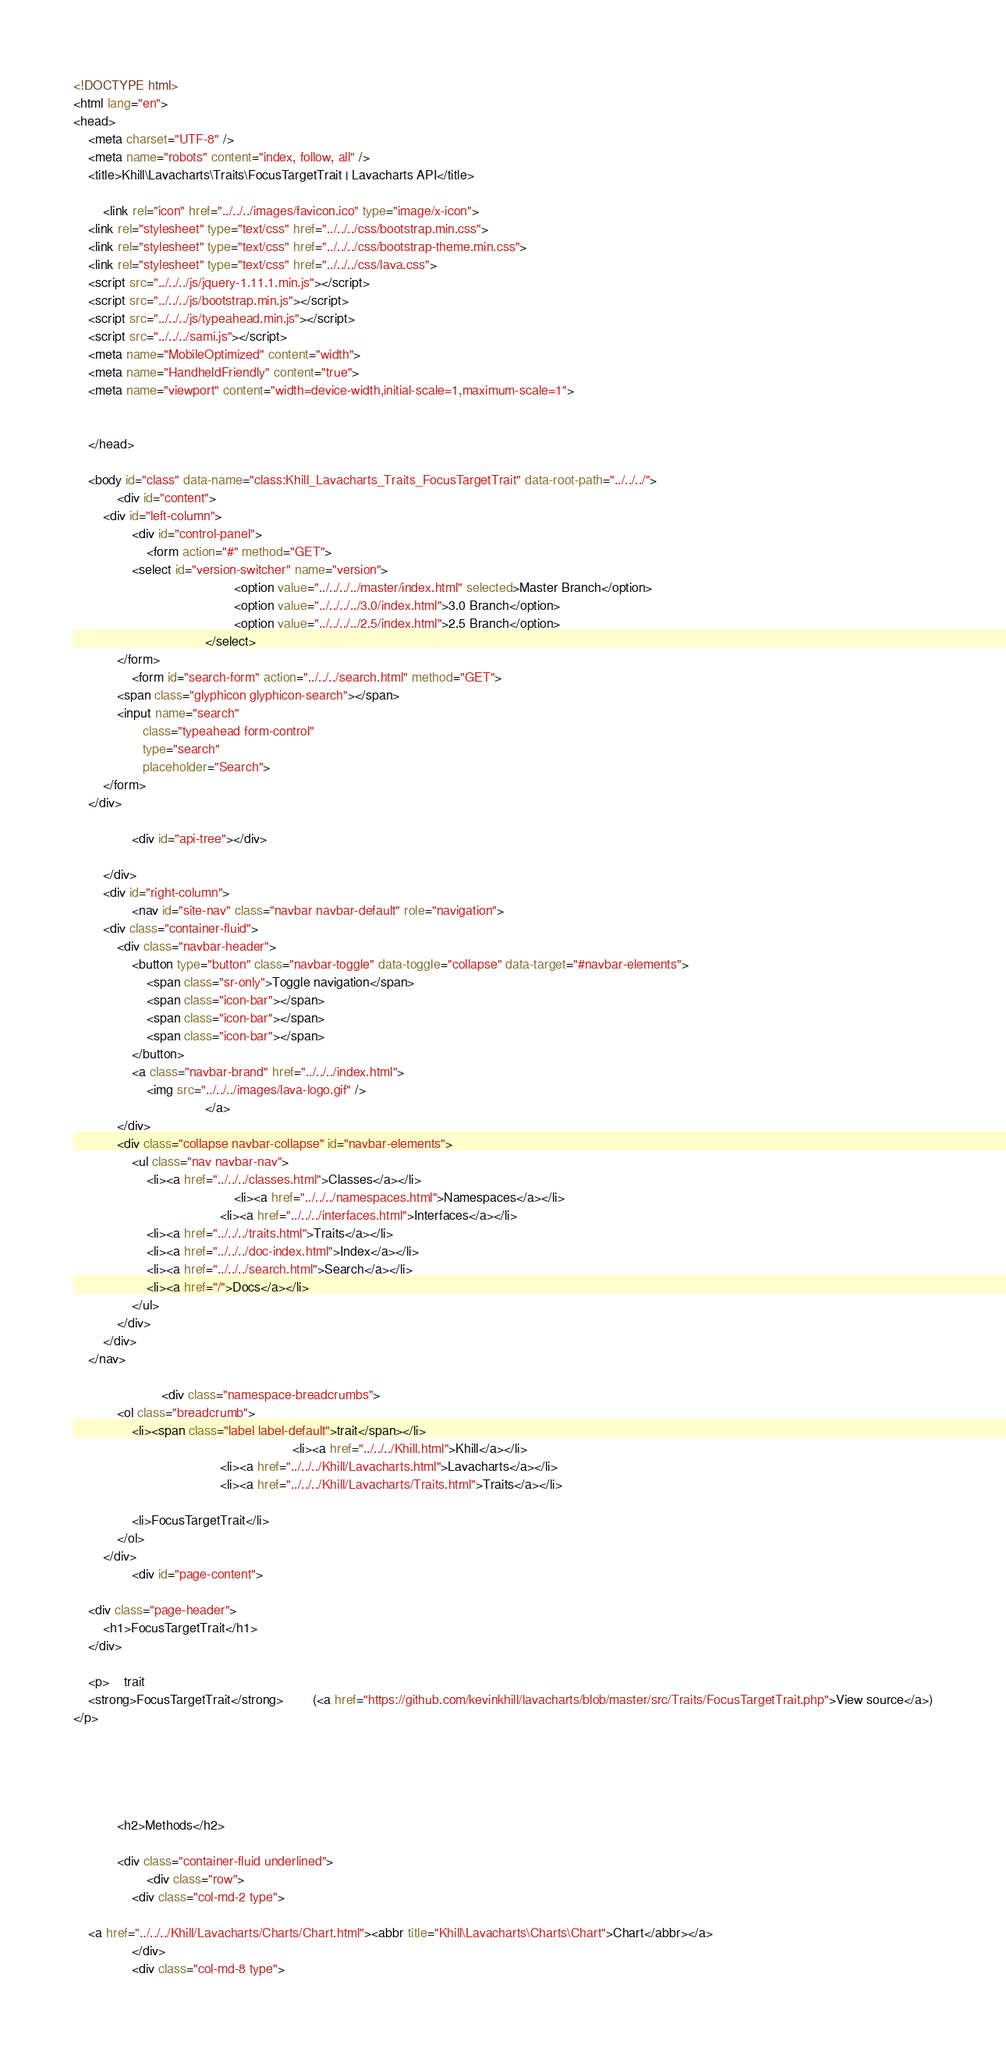Convert code to text. <code><loc_0><loc_0><loc_500><loc_500><_HTML_><!DOCTYPE html>
<html lang="en">
<head>
    <meta charset="UTF-8" />
    <meta name="robots" content="index, follow, all" />
    <title>Khill\Lavacharts\Traits\FocusTargetTrait | Lavacharts API</title>

        <link rel="icon" href="../../../images/favicon.ico" type="image/x-icon">
    <link rel="stylesheet" type="text/css" href="../../../css/bootstrap.min.css">
    <link rel="stylesheet" type="text/css" href="../../../css/bootstrap-theme.min.css">
    <link rel="stylesheet" type="text/css" href="../../../css/lava.css">
    <script src="../../../js/jquery-1.11.1.min.js"></script>
    <script src="../../../js/bootstrap.min.js"></script>
    <script src="../../../js/typeahead.min.js"></script>
    <script src="../../../sami.js"></script>
    <meta name="MobileOptimized" content="width">
    <meta name="HandheldFriendly" content="true">
    <meta name="viewport" content="width=device-width,initial-scale=1,maximum-scale=1">

    
    </head>

    <body id="class" data-name="class:Khill_Lavacharts_Traits_FocusTargetTrait" data-root-path="../../../">
            <div id="content">
        <div id="left-column">
                <div id="control-panel">
                    <form action="#" method="GET">
                <select id="version-switcher" name="version">
                                            <option value="../../../../master/index.html" selected>Master Branch</option>
                                            <option value="../../../../3.0/index.html">3.0 Branch</option>
                                            <option value="../../../../2.5/index.html">2.5 Branch</option>
                                    </select>
            </form>
                <form id="search-form" action="../../../search.html" method="GET">
            <span class="glyphicon glyphicon-search"></span>
            <input name="search"
                   class="typeahead form-control"
                   type="search"
                   placeholder="Search">
        </form>
    </div>

                <div id="api-tree"></div>

        </div>
        <div id="right-column">
                <nav id="site-nav" class="navbar navbar-default" role="navigation">
        <div class="container-fluid">
            <div class="navbar-header">
                <button type="button" class="navbar-toggle" data-toggle="collapse" data-target="#navbar-elements">
                    <span class="sr-only">Toggle navigation</span>
                    <span class="icon-bar"></span>
                    <span class="icon-bar"></span>
                    <span class="icon-bar"></span>
                </button>
                <a class="navbar-brand" href="../../../index.html">
                    <img src="../../../images/lava-logo.gif" />
                                    </a>
            </div>
            <div class="collapse navbar-collapse" id="navbar-elements">
                <ul class="nav navbar-nav">
                    <li><a href="../../../classes.html">Classes</a></li>
                                            <li><a href="../../../namespaces.html">Namespaces</a></li>
                                        <li><a href="../../../interfaces.html">Interfaces</a></li>
                    <li><a href="../../../traits.html">Traits</a></li>
                    <li><a href="../../../doc-index.html">Index</a></li>
                    <li><a href="../../../search.html">Search</a></li>
                    <li><a href="/">Docs</a></li>
                </ul>
            </div>
        </div>
    </nav>

                        <div class="namespace-breadcrumbs">
            <ol class="breadcrumb">
                <li><span class="label label-default">trait</span></li>
                                                            <li><a href="../../../Khill.html">Khill</a></li>
                                        <li><a href="../../../Khill/Lavacharts.html">Lavacharts</a></li>
                                        <li><a href="../../../Khill/Lavacharts/Traits.html">Traits</a></li>
    
                <li>FocusTargetTrait</li>
            </ol>
        </div>
                <div id="page-content">
                
    <div class="page-header">
        <h1>FocusTargetTrait</h1>
    </div>

    <p>    trait
    <strong>FocusTargetTrait</strong>        (<a href="https://github.com/kevinkhill/lavacharts/blob/master/src/Traits/FocusTargetTrait.php">View source</a>)
</p>

    
    
    
    
            <h2>Methods</h2>

            <div class="container-fluid underlined">
                    <div class="row">
                <div class="col-md-2 type">
                    
    <a href="../../../Khill/Lavacharts/Charts/Chart.html"><abbr title="Khill\Lavacharts\Charts\Chart">Chart</abbr></a>
                </div>
                <div class="col-md-8 type"></code> 